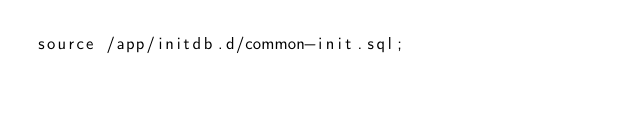<code> <loc_0><loc_0><loc_500><loc_500><_SQL_>source /app/initdb.d/common-init.sql;
</code> 